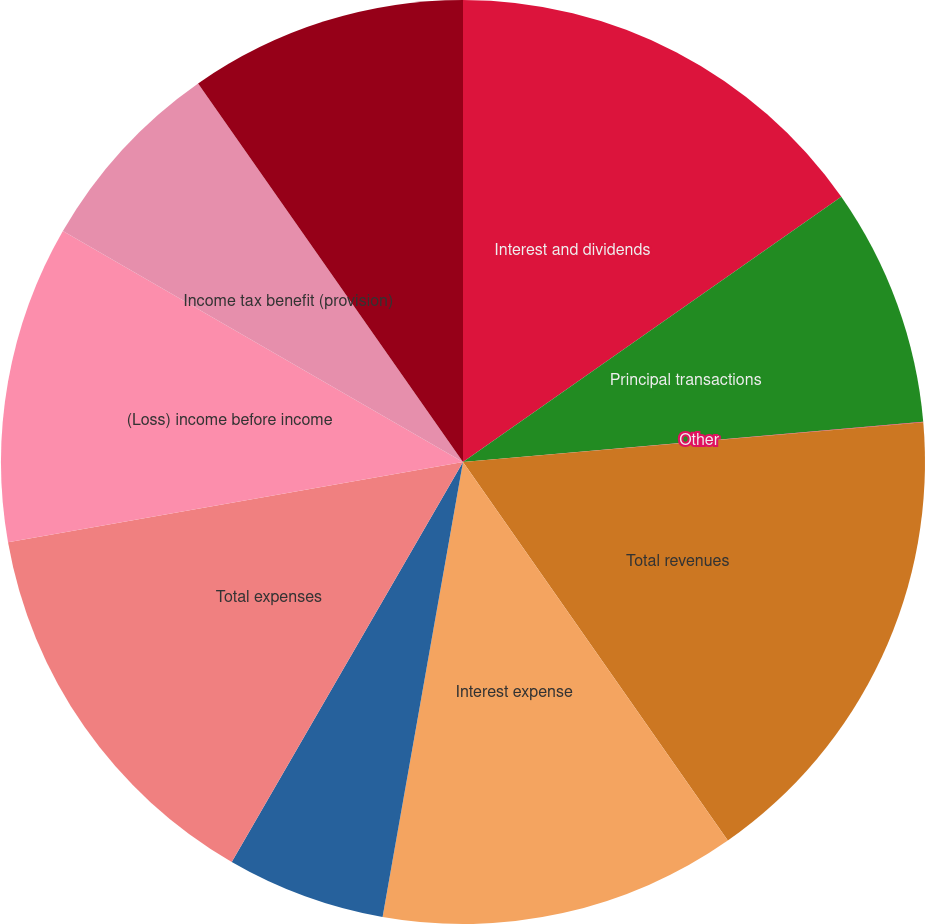<chart> <loc_0><loc_0><loc_500><loc_500><pie_chart><fcel>Interest and dividends<fcel>Principal transactions<fcel>Other<fcel>Total revenues<fcel>Interest expense<fcel>Non-interest expenses<fcel>Total expenses<fcel>(Loss) income before income<fcel>Income tax benefit (provision)<fcel>(Loss) income before equity in<nl><fcel>15.27%<fcel>8.34%<fcel>0.02%<fcel>16.66%<fcel>12.5%<fcel>5.56%<fcel>13.88%<fcel>11.11%<fcel>6.95%<fcel>9.72%<nl></chart> 